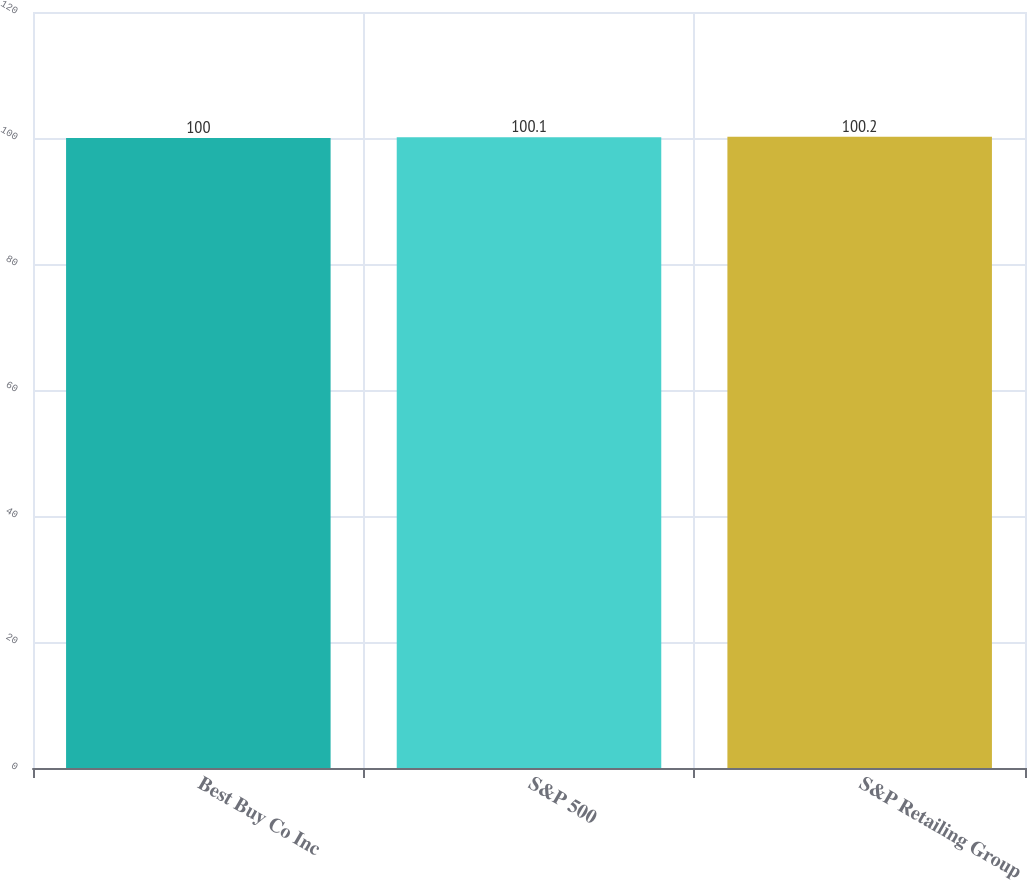Convert chart. <chart><loc_0><loc_0><loc_500><loc_500><bar_chart><fcel>Best Buy Co Inc<fcel>S&P 500<fcel>S&P Retailing Group<nl><fcel>100<fcel>100.1<fcel>100.2<nl></chart> 